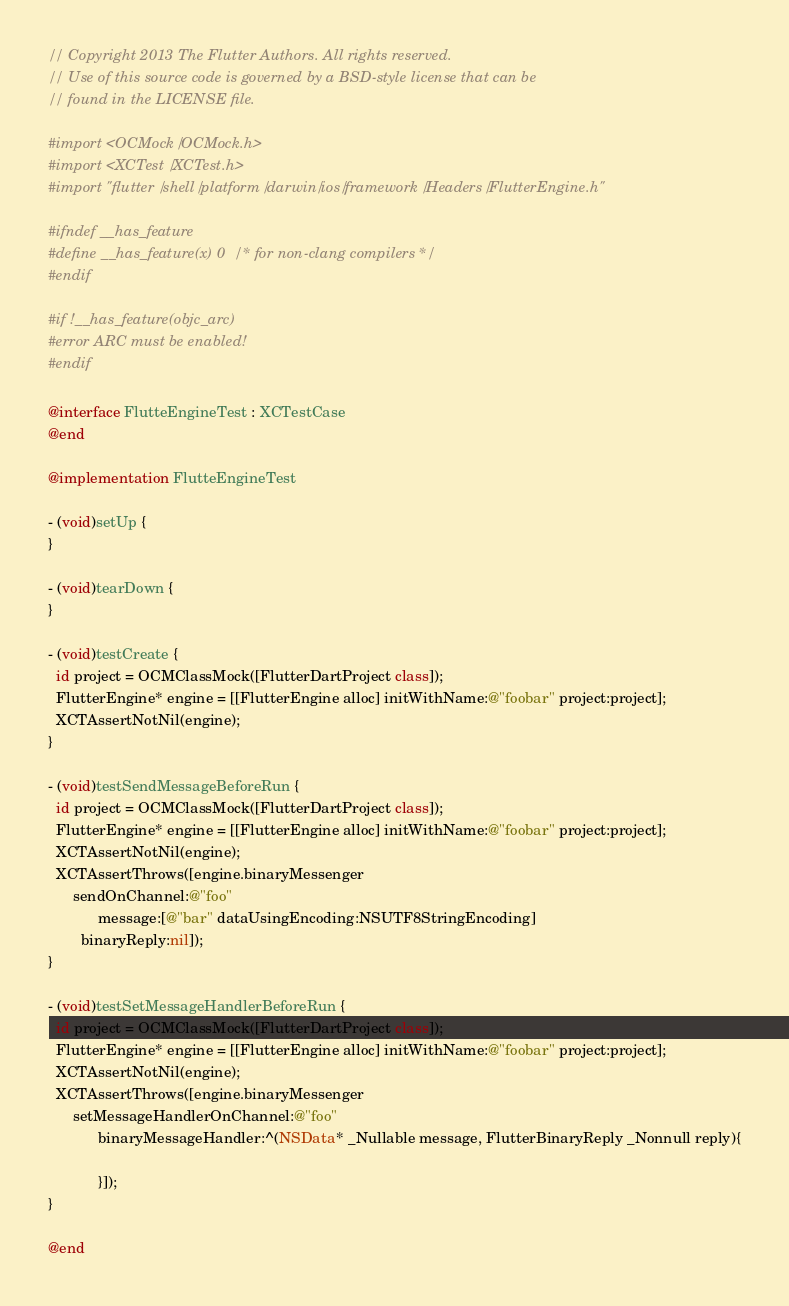<code> <loc_0><loc_0><loc_500><loc_500><_ObjectiveC_>// Copyright 2013 The Flutter Authors. All rights reserved.
// Use of this source code is governed by a BSD-style license that can be
// found in the LICENSE file.

#import <OCMock/OCMock.h>
#import <XCTest/XCTest.h>
#import "flutter/shell/platform/darwin/ios/framework/Headers/FlutterEngine.h"

#ifndef __has_feature
#define __has_feature(x) 0 /* for non-clang compilers */
#endif

#if !__has_feature(objc_arc)
#error ARC must be enabled!
#endif

@interface FlutteEngineTest : XCTestCase
@end

@implementation FlutteEngineTest

- (void)setUp {
}

- (void)tearDown {
}

- (void)testCreate {
  id project = OCMClassMock([FlutterDartProject class]);
  FlutterEngine* engine = [[FlutterEngine alloc] initWithName:@"foobar" project:project];
  XCTAssertNotNil(engine);
}

- (void)testSendMessageBeforeRun {
  id project = OCMClassMock([FlutterDartProject class]);
  FlutterEngine* engine = [[FlutterEngine alloc] initWithName:@"foobar" project:project];
  XCTAssertNotNil(engine);
  XCTAssertThrows([engine.binaryMessenger
      sendOnChannel:@"foo"
            message:[@"bar" dataUsingEncoding:NSUTF8StringEncoding]
        binaryReply:nil]);
}

- (void)testSetMessageHandlerBeforeRun {
  id project = OCMClassMock([FlutterDartProject class]);
  FlutterEngine* engine = [[FlutterEngine alloc] initWithName:@"foobar" project:project];
  XCTAssertNotNil(engine);
  XCTAssertThrows([engine.binaryMessenger
      setMessageHandlerOnChannel:@"foo"
            binaryMessageHandler:^(NSData* _Nullable message, FlutterBinaryReply _Nonnull reply){

            }]);
}

@end
</code> 